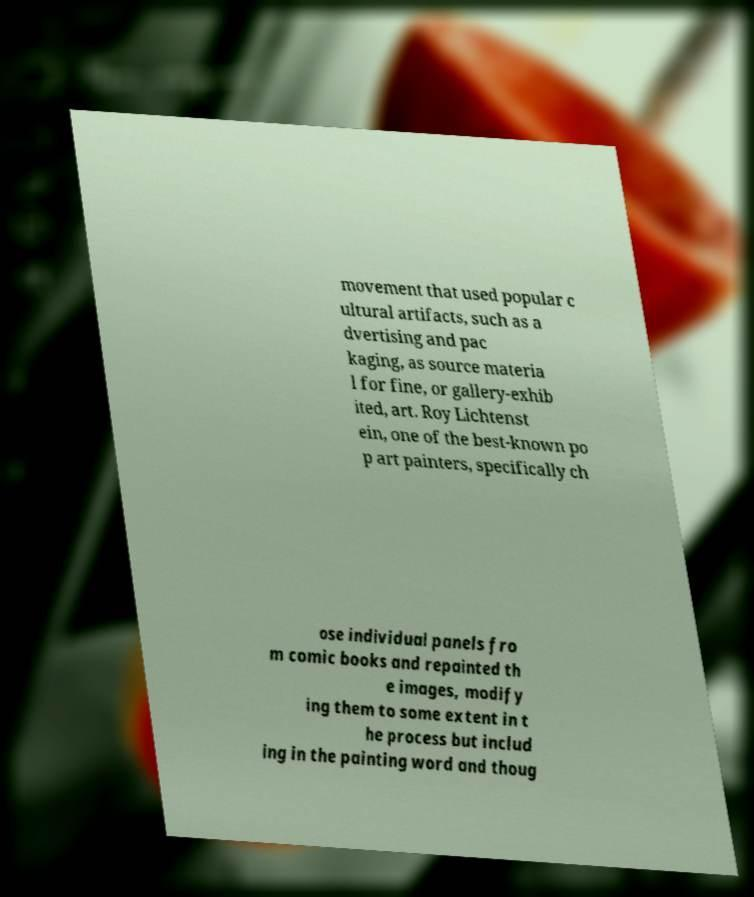There's text embedded in this image that I need extracted. Can you transcribe it verbatim? movement that used popular c ultural artifacts, such as a dvertising and pac kaging, as source materia l for fine, or gallery-exhib ited, art. Roy Lichtenst ein, one of the best-known po p art painters, specifically ch ose individual panels fro m comic books and repainted th e images, modify ing them to some extent in t he process but includ ing in the painting word and thoug 